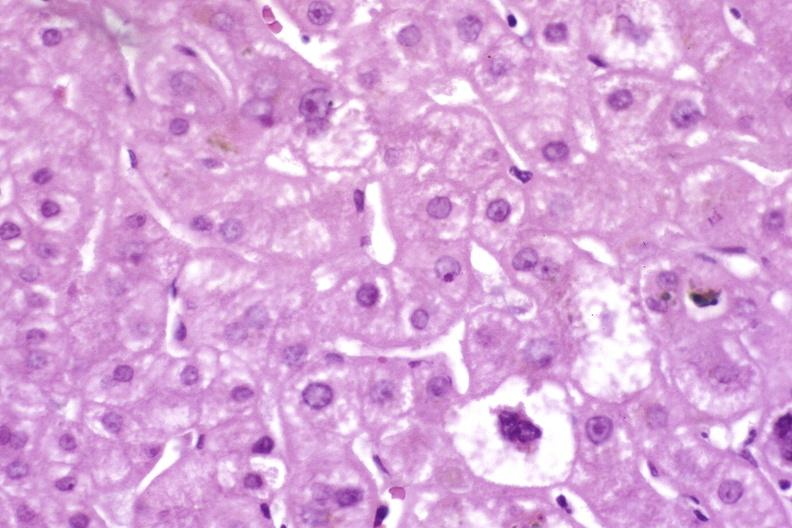what is present?
Answer the question using a single word or phrase. Liver 